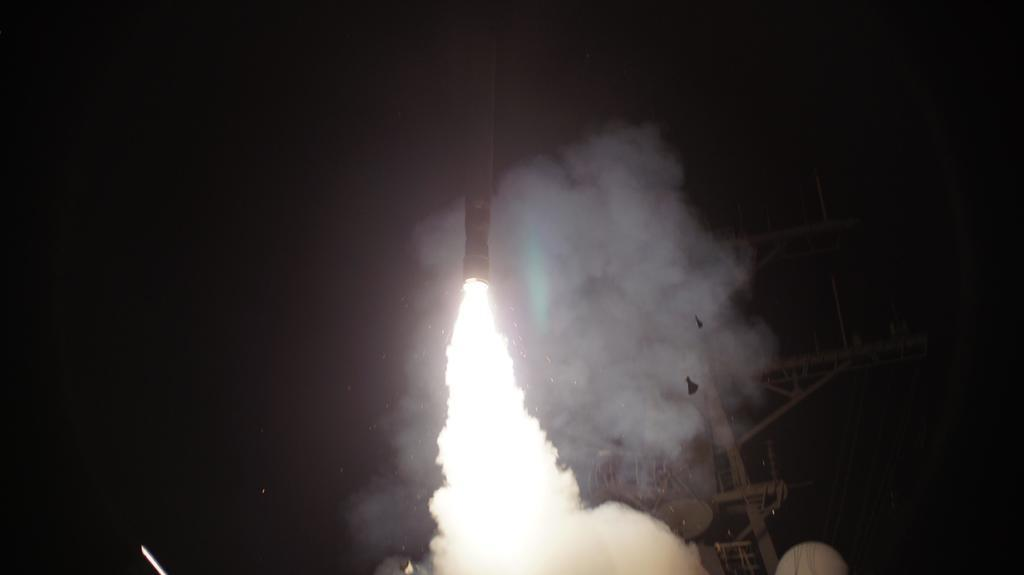What is the main subject of the image? The main subject of the image is a rocket. What can be observed about the rocket in the image? The rocket has fire in the image. Are there any other objects near the rocket? Yes, there is an object at the side of the rocket. What else can be seen in the image? There is a rod in the image. What type of engine is powering the rocket in the image? There is no specific engine mentioned or visible in the image, so it cannot be determined from the image alone. 